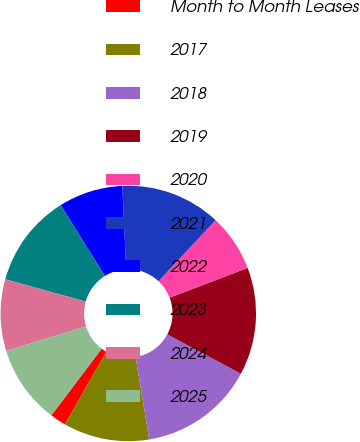Convert chart. <chart><loc_0><loc_0><loc_500><loc_500><pie_chart><fcel>Month to Month Leases<fcel>2017<fcel>2018<fcel>2019<fcel>2020<fcel>2021<fcel>2022<fcel>2023<fcel>2024<fcel>2025<nl><fcel>2.03%<fcel>10.89%<fcel>14.55%<fcel>13.63%<fcel>7.22%<fcel>12.72%<fcel>8.14%<fcel>11.8%<fcel>9.05%<fcel>9.97%<nl></chart> 